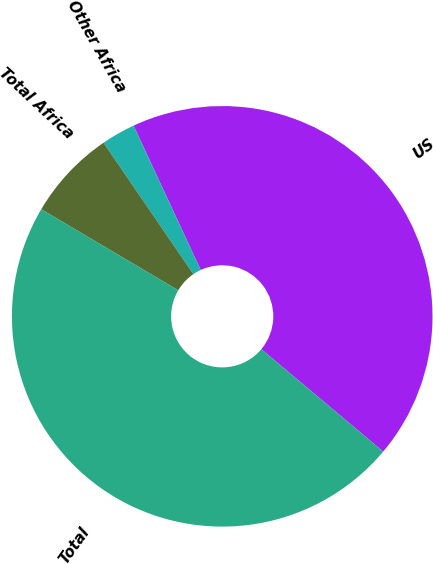Convert chart. <chart><loc_0><loc_0><loc_500><loc_500><pie_chart><fcel>US<fcel>Other Africa<fcel>Total Africa<fcel>Total<nl><fcel>43.05%<fcel>2.62%<fcel>6.95%<fcel>47.38%<nl></chart> 